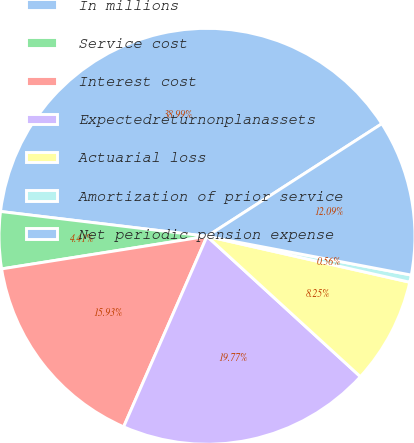<chart> <loc_0><loc_0><loc_500><loc_500><pie_chart><fcel>In millions<fcel>Service cost<fcel>Interest cost<fcel>Expectedreturnonplanassets<fcel>Actuarial loss<fcel>Amortization of prior service<fcel>Net periodic pension expense<nl><fcel>38.99%<fcel>4.41%<fcel>15.93%<fcel>19.77%<fcel>8.25%<fcel>0.56%<fcel>12.09%<nl></chart> 